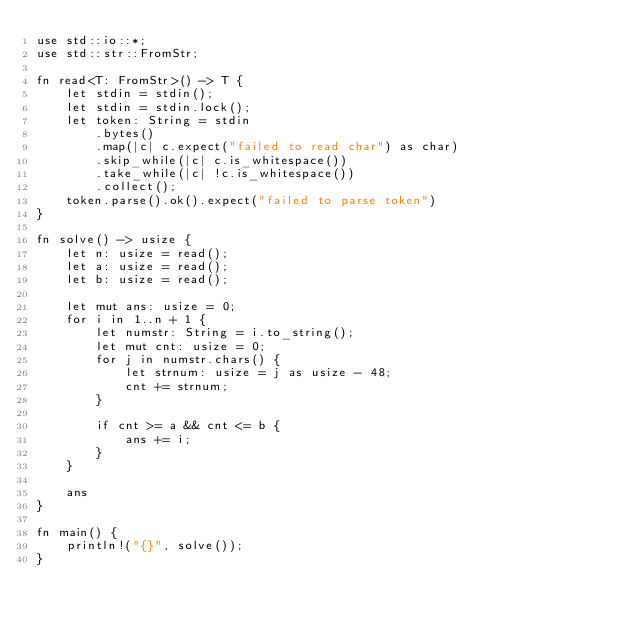<code> <loc_0><loc_0><loc_500><loc_500><_Rust_>use std::io::*;
use std::str::FromStr;

fn read<T: FromStr>() -> T {
    let stdin = stdin();
    let stdin = stdin.lock();
    let token: String = stdin
        .bytes()
        .map(|c| c.expect("failed to read char") as char)
        .skip_while(|c| c.is_whitespace())
        .take_while(|c| !c.is_whitespace())
        .collect();
    token.parse().ok().expect("failed to parse token")
}

fn solve() -> usize {
    let n: usize = read();
    let a: usize = read();
    let b: usize = read();

    let mut ans: usize = 0;
    for i in 1..n + 1 {
        let numstr: String = i.to_string();
        let mut cnt: usize = 0;
        for j in numstr.chars() {
            let strnum: usize = j as usize - 48;
            cnt += strnum;
        }

        if cnt >= a && cnt <= b {
            ans += i;
        }
    }

    ans
}

fn main() {
    println!("{}", solve());
}
</code> 